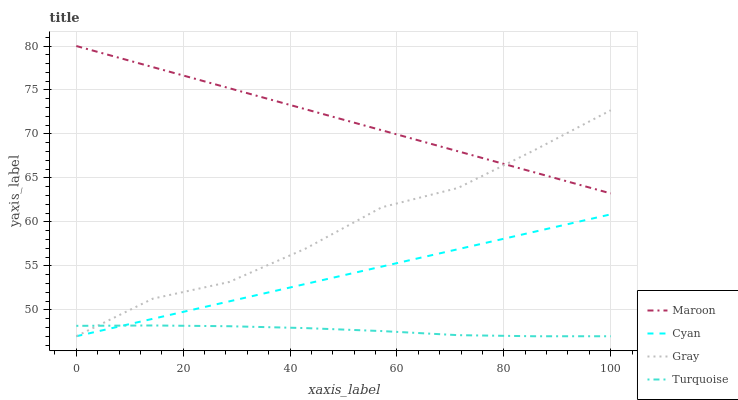Does Turquoise have the minimum area under the curve?
Answer yes or no. Yes. Does Maroon have the maximum area under the curve?
Answer yes or no. Yes. Does Maroon have the minimum area under the curve?
Answer yes or no. No. Does Turquoise have the maximum area under the curve?
Answer yes or no. No. Is Cyan the smoothest?
Answer yes or no. Yes. Is Gray the roughest?
Answer yes or no. Yes. Is Turquoise the smoothest?
Answer yes or no. No. Is Turquoise the roughest?
Answer yes or no. No. Does Cyan have the lowest value?
Answer yes or no. Yes. Does Maroon have the lowest value?
Answer yes or no. No. Does Maroon have the highest value?
Answer yes or no. Yes. Does Turquoise have the highest value?
Answer yes or no. No. Is Turquoise less than Maroon?
Answer yes or no. Yes. Is Maroon greater than Cyan?
Answer yes or no. Yes. Does Maroon intersect Gray?
Answer yes or no. Yes. Is Maroon less than Gray?
Answer yes or no. No. Is Maroon greater than Gray?
Answer yes or no. No. Does Turquoise intersect Maroon?
Answer yes or no. No. 